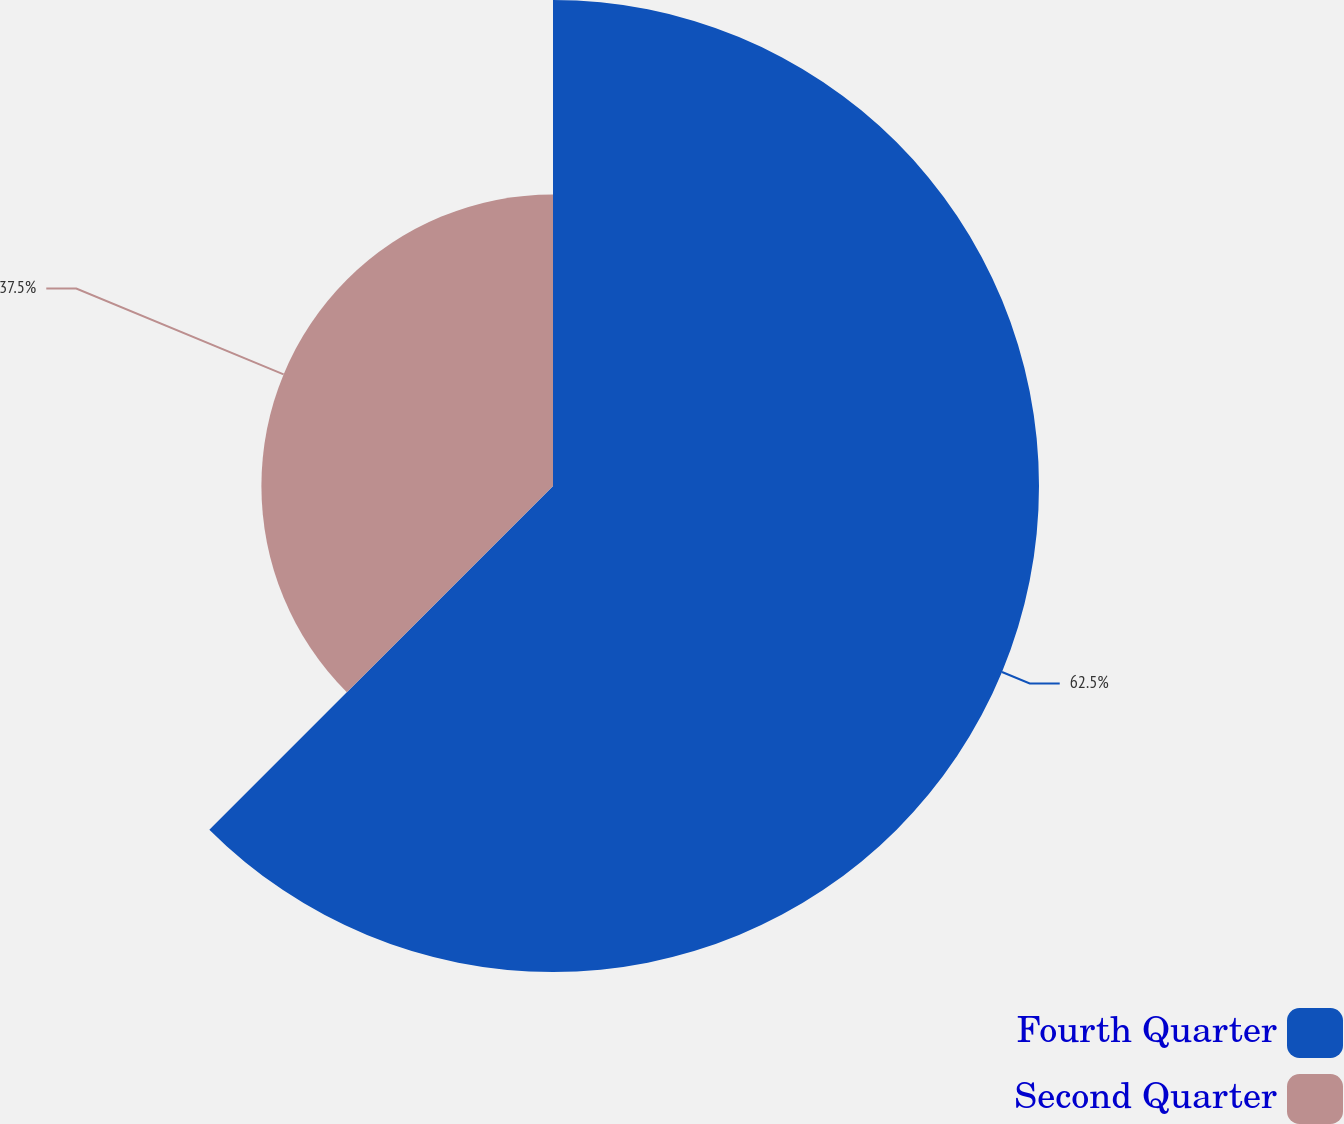Convert chart. <chart><loc_0><loc_0><loc_500><loc_500><pie_chart><fcel>Fourth Quarter<fcel>Second Quarter<nl><fcel>62.5%<fcel>37.5%<nl></chart> 